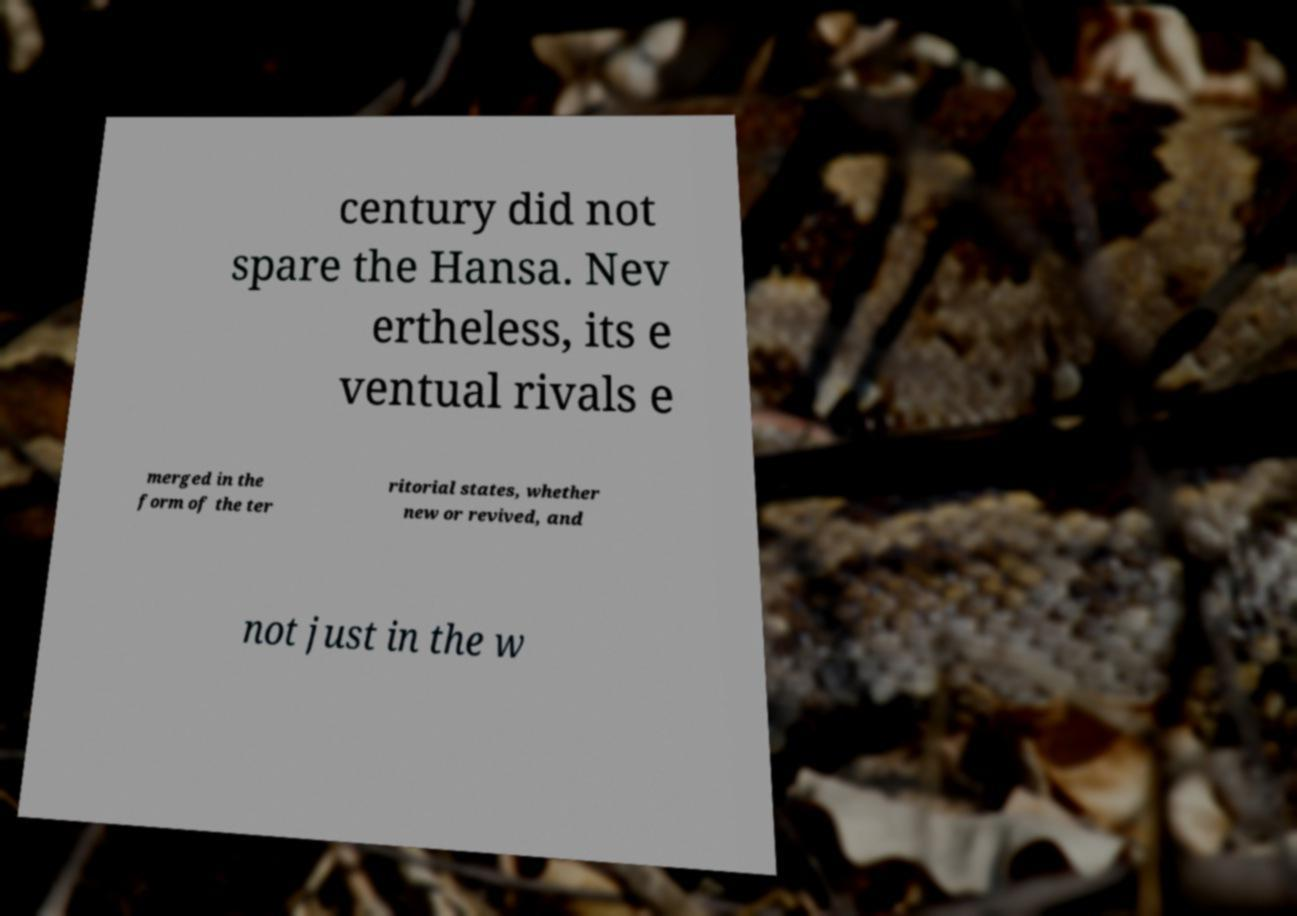I need the written content from this picture converted into text. Can you do that? century did not spare the Hansa. Nev ertheless, its e ventual rivals e merged in the form of the ter ritorial states, whether new or revived, and not just in the w 